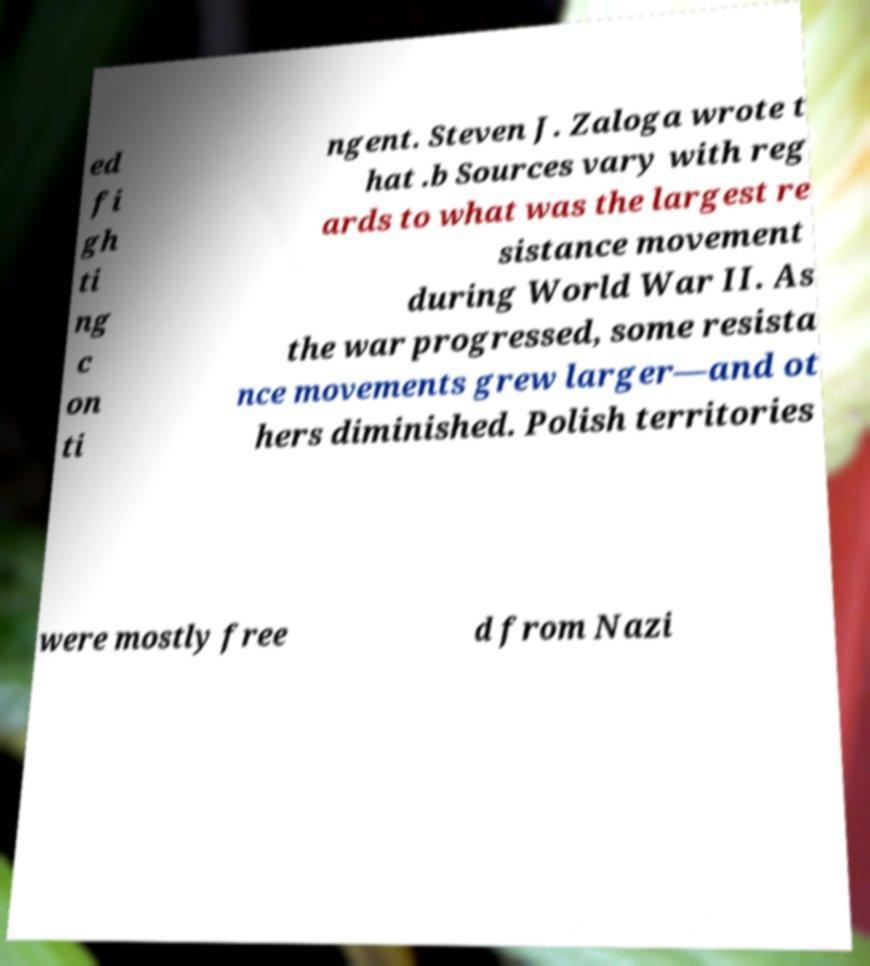For documentation purposes, I need the text within this image transcribed. Could you provide that? ed fi gh ti ng c on ti ngent. Steven J. Zaloga wrote t hat .b Sources vary with reg ards to what was the largest re sistance movement during World War II. As the war progressed, some resista nce movements grew larger—and ot hers diminished. Polish territories were mostly free d from Nazi 